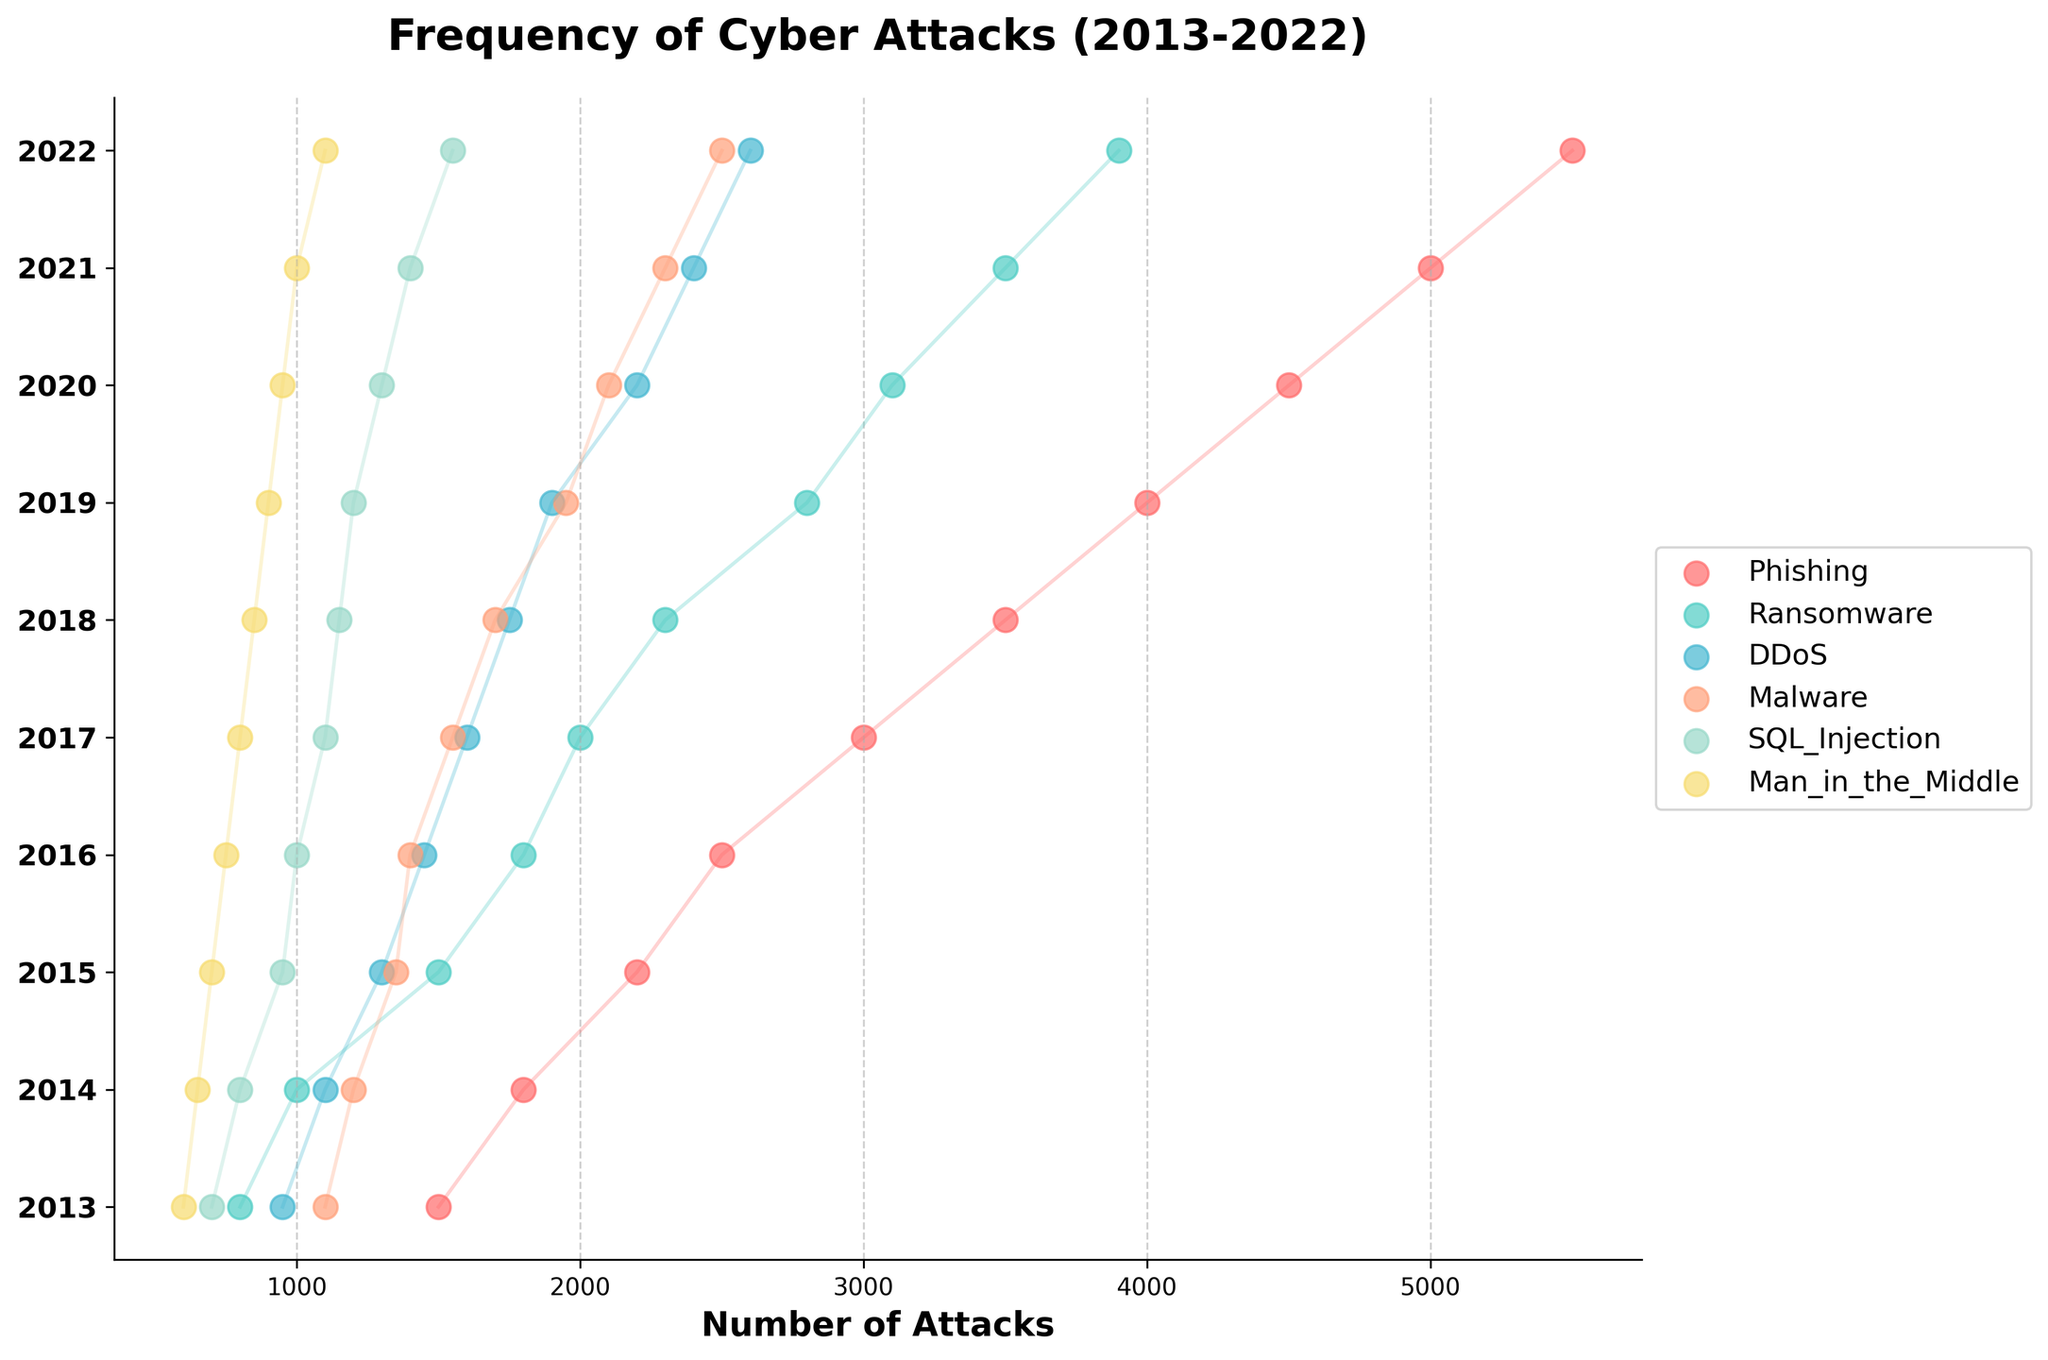What's the title of the plot? The title is text usually located at the top of the plot. Reading the top area, you can find "Frequency of Cyber Attacks (2013-2022)"
Answer: Frequency of Cyber Attacks (2013-2022) What are the types of cyber-attacks shown in the plot? The legend on the right side of the plot lists the types. They include Phishing, Ransomware, DDoS, Malware, SQL Injection, and Man in the Middle
Answer: Phishing, Ransomware, DDoS, Malware, SQL Injection, Man in the Middle Which year had the highest number of phishing attacks? By looking at the dots for Phishing, follow the highest point on the y-axis which represents years. The year with the highest dot is 2022
Answer: 2022 How does the frequency of ransomware attacks in 2015 compare to 2022? Check the y-axis for 2015 and 2022, then look at the corresponding dots for Ransomware. Ransomware attacks were 1500 in 2015 and grew to 3900 in 2022
Answer: The frequency significantly increased Which cyber-attack type had the least frequency in 2013? Look at the y-axis for 2013 and find the lowest dot among all attack types. The lowest dot corresponds to "Man in the Middle" with 600 attacks
Answer: Man in the Middle What is the difference in the number of DDoS attacks between 2015 and 2019? Locate the DDoS dots for 2015 (1300 attacks) and 2019 (1900 attacks) and subtract 1300 from 1900
Answer: 600 What is the trend for Malware attacks from 2013 to 2022? Follow the Malware dots from left to right (2013 to 2022) and note the overall direction. The dots show a consistent upward trend
Answer: Increasing In which year did phishing attacks surpass 4000 incidents? Find the phishing dots and see which year exceeds 4000. The year after 4000 is exceeded is 2019
Answer: 2019 Among SQL Injection and Man in the Middle, which attack had more incidents in 2021? Compare the SQL Injection and Man in the Middle dots for 2021. SQL Injection had 1400 and Man in the Middle had 1000
Answer: SQL Injection What's the average frequency of DDoS attacks in the years 2014, 2016, and 2018? Locate the DDoS dots for those years (1100 in 2014, 1450 in 2016, and 1750 in 2018), sum them up and divide by 3. (1100 + 1450 + 1750) / 3 = 1433.33
Answer: 1433.33 